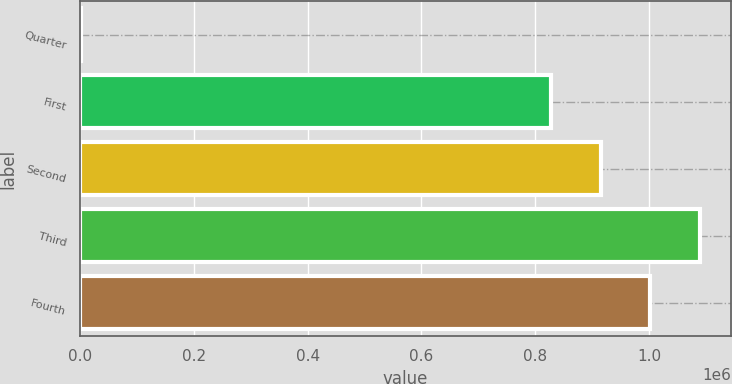<chart> <loc_0><loc_0><loc_500><loc_500><bar_chart><fcel>Quarter<fcel>First<fcel>Second<fcel>Third<fcel>Fourth<nl><fcel>2017<fcel>828293<fcel>915385<fcel>1.08957e+06<fcel>1.00248e+06<nl></chart> 